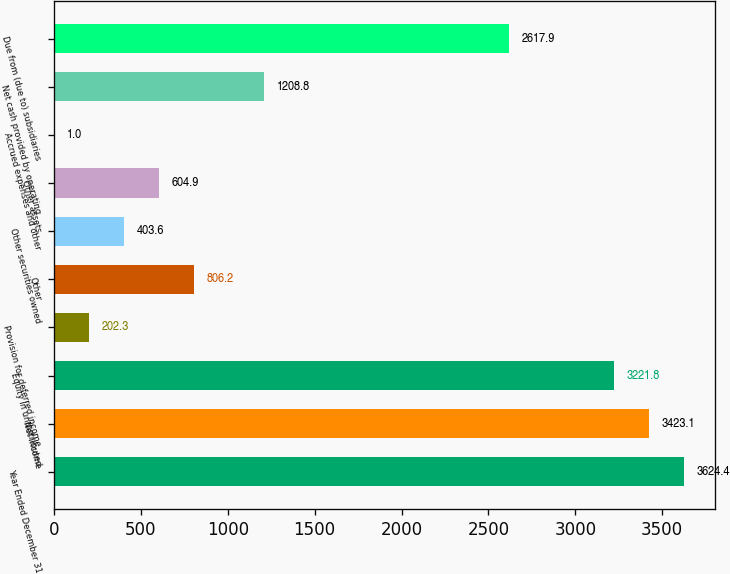Convert chart. <chart><loc_0><loc_0><loc_500><loc_500><bar_chart><fcel>Year Ended December 31<fcel>Net income<fcel>Equity in undistributed<fcel>Provision for deferred income<fcel>Other<fcel>Other securities owned<fcel>Other assets<fcel>Accrued expenses and other<fcel>Net cash provided by operating<fcel>Due from (due to) subsidiaries<nl><fcel>3624.4<fcel>3423.1<fcel>3221.8<fcel>202.3<fcel>806.2<fcel>403.6<fcel>604.9<fcel>1<fcel>1208.8<fcel>2617.9<nl></chart> 